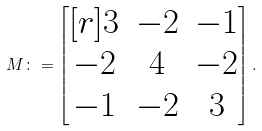<formula> <loc_0><loc_0><loc_500><loc_500>M \colon = \begin{bmatrix} [ r ] 3 & - 2 & - 1 \\ - 2 & 4 & - 2 \\ - 1 & - 2 & 3 \end{bmatrix} .</formula> 